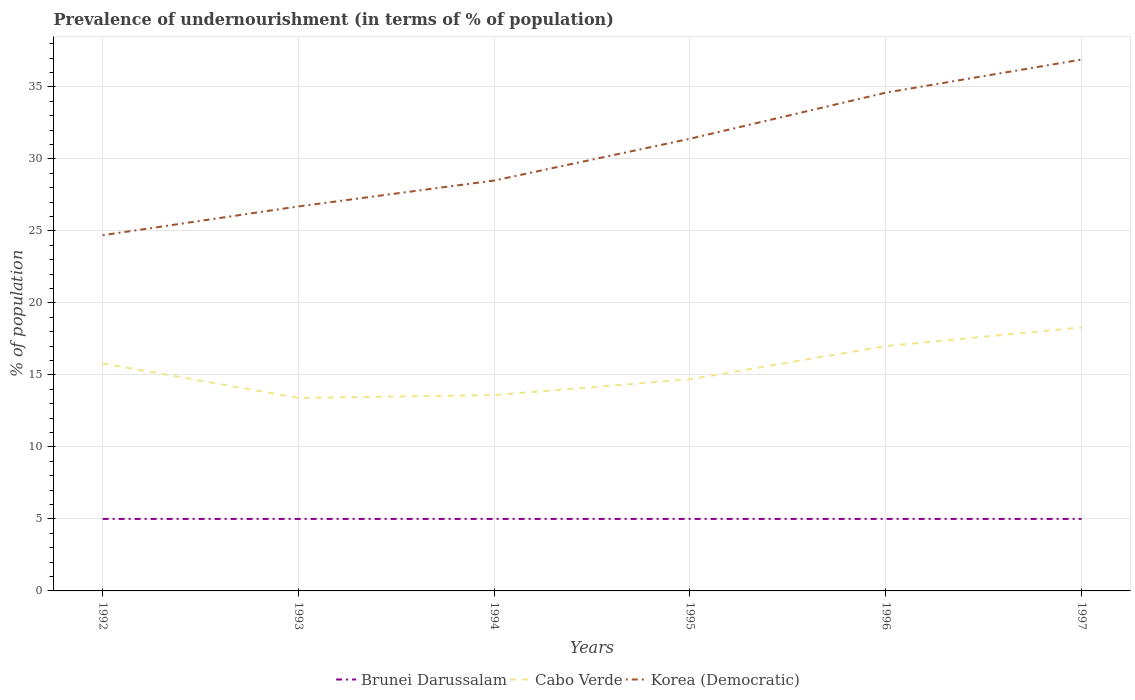Does the line corresponding to Korea (Democratic) intersect with the line corresponding to Cabo Verde?
Provide a succinct answer. No. Is the number of lines equal to the number of legend labels?
Ensure brevity in your answer.  Yes. Across all years, what is the maximum percentage of undernourished population in Cabo Verde?
Make the answer very short. 13.4. What is the total percentage of undernourished population in Korea (Democratic) in the graph?
Offer a terse response. -3.8. Is the percentage of undernourished population in Brunei Darussalam strictly greater than the percentage of undernourished population in Cabo Verde over the years?
Your answer should be compact. Yes. What is the difference between two consecutive major ticks on the Y-axis?
Provide a short and direct response. 5. Are the values on the major ticks of Y-axis written in scientific E-notation?
Provide a succinct answer. No. Does the graph contain any zero values?
Give a very brief answer. No. What is the title of the graph?
Make the answer very short. Prevalence of undernourishment (in terms of % of population). Does "Niger" appear as one of the legend labels in the graph?
Your answer should be compact. No. What is the label or title of the X-axis?
Provide a succinct answer. Years. What is the label or title of the Y-axis?
Your answer should be very brief. % of population. What is the % of population in Brunei Darussalam in 1992?
Offer a terse response. 5. What is the % of population of Cabo Verde in 1992?
Offer a very short reply. 15.8. What is the % of population in Korea (Democratic) in 1992?
Your answer should be compact. 24.7. What is the % of population in Korea (Democratic) in 1993?
Your response must be concise. 26.7. What is the % of population in Brunei Darussalam in 1994?
Make the answer very short. 5. What is the % of population of Korea (Democratic) in 1994?
Make the answer very short. 28.5. What is the % of population of Cabo Verde in 1995?
Ensure brevity in your answer.  14.7. What is the % of population of Korea (Democratic) in 1995?
Make the answer very short. 31.4. What is the % of population of Brunei Darussalam in 1996?
Make the answer very short. 5. What is the % of population of Cabo Verde in 1996?
Your answer should be compact. 17. What is the % of population in Korea (Democratic) in 1996?
Your answer should be very brief. 34.6. What is the % of population in Brunei Darussalam in 1997?
Offer a very short reply. 5. What is the % of population in Korea (Democratic) in 1997?
Provide a succinct answer. 36.9. Across all years, what is the maximum % of population in Cabo Verde?
Offer a terse response. 18.3. Across all years, what is the maximum % of population of Korea (Democratic)?
Make the answer very short. 36.9. Across all years, what is the minimum % of population of Brunei Darussalam?
Your response must be concise. 5. Across all years, what is the minimum % of population in Korea (Democratic)?
Give a very brief answer. 24.7. What is the total % of population of Brunei Darussalam in the graph?
Provide a succinct answer. 30. What is the total % of population of Cabo Verde in the graph?
Ensure brevity in your answer.  92.8. What is the total % of population in Korea (Democratic) in the graph?
Provide a short and direct response. 182.8. What is the difference between the % of population of Brunei Darussalam in 1992 and that in 1994?
Offer a terse response. 0. What is the difference between the % of population of Cabo Verde in 1992 and that in 1994?
Offer a very short reply. 2.2. What is the difference between the % of population of Korea (Democratic) in 1992 and that in 1994?
Provide a succinct answer. -3.8. What is the difference between the % of population in Brunei Darussalam in 1992 and that in 1995?
Your response must be concise. 0. What is the difference between the % of population in Cabo Verde in 1992 and that in 1995?
Make the answer very short. 1.1. What is the difference between the % of population of Cabo Verde in 1992 and that in 1997?
Provide a succinct answer. -2.5. What is the difference between the % of population in Korea (Democratic) in 1992 and that in 1997?
Provide a short and direct response. -12.2. What is the difference between the % of population in Brunei Darussalam in 1993 and that in 1994?
Your answer should be compact. 0. What is the difference between the % of population in Brunei Darussalam in 1993 and that in 1995?
Make the answer very short. 0. What is the difference between the % of population of Korea (Democratic) in 1993 and that in 1995?
Keep it short and to the point. -4.7. What is the difference between the % of population in Brunei Darussalam in 1993 and that in 1996?
Offer a terse response. 0. What is the difference between the % of population of Korea (Democratic) in 1993 and that in 1996?
Offer a very short reply. -7.9. What is the difference between the % of population of Cabo Verde in 1993 and that in 1997?
Offer a very short reply. -4.9. What is the difference between the % of population in Korea (Democratic) in 1993 and that in 1997?
Offer a very short reply. -10.2. What is the difference between the % of population in Cabo Verde in 1994 and that in 1995?
Offer a terse response. -1.1. What is the difference between the % of population of Korea (Democratic) in 1994 and that in 1995?
Provide a succinct answer. -2.9. What is the difference between the % of population of Brunei Darussalam in 1994 and that in 1997?
Provide a succinct answer. 0. What is the difference between the % of population in Cabo Verde in 1994 and that in 1997?
Your answer should be very brief. -4.7. What is the difference between the % of population in Cabo Verde in 1995 and that in 1996?
Offer a very short reply. -2.3. What is the difference between the % of population in Brunei Darussalam in 1995 and that in 1997?
Ensure brevity in your answer.  0. What is the difference between the % of population in Cabo Verde in 1995 and that in 1997?
Ensure brevity in your answer.  -3.6. What is the difference between the % of population in Korea (Democratic) in 1996 and that in 1997?
Keep it short and to the point. -2.3. What is the difference between the % of population in Brunei Darussalam in 1992 and the % of population in Cabo Verde in 1993?
Give a very brief answer. -8.4. What is the difference between the % of population of Brunei Darussalam in 1992 and the % of population of Korea (Democratic) in 1993?
Make the answer very short. -21.7. What is the difference between the % of population in Brunei Darussalam in 1992 and the % of population in Korea (Democratic) in 1994?
Ensure brevity in your answer.  -23.5. What is the difference between the % of population of Cabo Verde in 1992 and the % of population of Korea (Democratic) in 1994?
Your response must be concise. -12.7. What is the difference between the % of population of Brunei Darussalam in 1992 and the % of population of Korea (Democratic) in 1995?
Your answer should be compact. -26.4. What is the difference between the % of population of Cabo Verde in 1992 and the % of population of Korea (Democratic) in 1995?
Your response must be concise. -15.6. What is the difference between the % of population of Brunei Darussalam in 1992 and the % of population of Korea (Democratic) in 1996?
Offer a very short reply. -29.6. What is the difference between the % of population in Cabo Verde in 1992 and the % of population in Korea (Democratic) in 1996?
Make the answer very short. -18.8. What is the difference between the % of population in Brunei Darussalam in 1992 and the % of population in Cabo Verde in 1997?
Your answer should be very brief. -13.3. What is the difference between the % of population of Brunei Darussalam in 1992 and the % of population of Korea (Democratic) in 1997?
Offer a very short reply. -31.9. What is the difference between the % of population in Cabo Verde in 1992 and the % of population in Korea (Democratic) in 1997?
Offer a terse response. -21.1. What is the difference between the % of population of Brunei Darussalam in 1993 and the % of population of Cabo Verde in 1994?
Provide a short and direct response. -8.6. What is the difference between the % of population of Brunei Darussalam in 1993 and the % of population of Korea (Democratic) in 1994?
Offer a terse response. -23.5. What is the difference between the % of population of Cabo Verde in 1993 and the % of population of Korea (Democratic) in 1994?
Your answer should be very brief. -15.1. What is the difference between the % of population in Brunei Darussalam in 1993 and the % of population in Korea (Democratic) in 1995?
Keep it short and to the point. -26.4. What is the difference between the % of population in Cabo Verde in 1993 and the % of population in Korea (Democratic) in 1995?
Your answer should be compact. -18. What is the difference between the % of population in Brunei Darussalam in 1993 and the % of population in Cabo Verde in 1996?
Offer a very short reply. -12. What is the difference between the % of population of Brunei Darussalam in 1993 and the % of population of Korea (Democratic) in 1996?
Your response must be concise. -29.6. What is the difference between the % of population in Cabo Verde in 1993 and the % of population in Korea (Democratic) in 1996?
Offer a very short reply. -21.2. What is the difference between the % of population in Brunei Darussalam in 1993 and the % of population in Korea (Democratic) in 1997?
Your answer should be compact. -31.9. What is the difference between the % of population of Cabo Verde in 1993 and the % of population of Korea (Democratic) in 1997?
Provide a short and direct response. -23.5. What is the difference between the % of population of Brunei Darussalam in 1994 and the % of population of Cabo Verde in 1995?
Make the answer very short. -9.7. What is the difference between the % of population of Brunei Darussalam in 1994 and the % of population of Korea (Democratic) in 1995?
Keep it short and to the point. -26.4. What is the difference between the % of population of Cabo Verde in 1994 and the % of population of Korea (Democratic) in 1995?
Offer a terse response. -17.8. What is the difference between the % of population in Brunei Darussalam in 1994 and the % of population in Cabo Verde in 1996?
Make the answer very short. -12. What is the difference between the % of population in Brunei Darussalam in 1994 and the % of population in Korea (Democratic) in 1996?
Give a very brief answer. -29.6. What is the difference between the % of population in Cabo Verde in 1994 and the % of population in Korea (Democratic) in 1996?
Give a very brief answer. -21. What is the difference between the % of population in Brunei Darussalam in 1994 and the % of population in Cabo Verde in 1997?
Offer a very short reply. -13.3. What is the difference between the % of population of Brunei Darussalam in 1994 and the % of population of Korea (Democratic) in 1997?
Your answer should be compact. -31.9. What is the difference between the % of population of Cabo Verde in 1994 and the % of population of Korea (Democratic) in 1997?
Offer a very short reply. -23.3. What is the difference between the % of population in Brunei Darussalam in 1995 and the % of population in Cabo Verde in 1996?
Ensure brevity in your answer.  -12. What is the difference between the % of population in Brunei Darussalam in 1995 and the % of population in Korea (Democratic) in 1996?
Your answer should be very brief. -29.6. What is the difference between the % of population of Cabo Verde in 1995 and the % of population of Korea (Democratic) in 1996?
Give a very brief answer. -19.9. What is the difference between the % of population in Brunei Darussalam in 1995 and the % of population in Cabo Verde in 1997?
Provide a short and direct response. -13.3. What is the difference between the % of population in Brunei Darussalam in 1995 and the % of population in Korea (Democratic) in 1997?
Provide a succinct answer. -31.9. What is the difference between the % of population of Cabo Verde in 1995 and the % of population of Korea (Democratic) in 1997?
Offer a terse response. -22.2. What is the difference between the % of population of Brunei Darussalam in 1996 and the % of population of Korea (Democratic) in 1997?
Keep it short and to the point. -31.9. What is the difference between the % of population in Cabo Verde in 1996 and the % of population in Korea (Democratic) in 1997?
Provide a short and direct response. -19.9. What is the average % of population of Cabo Verde per year?
Provide a short and direct response. 15.47. What is the average % of population of Korea (Democratic) per year?
Your answer should be very brief. 30.47. In the year 1992, what is the difference between the % of population in Brunei Darussalam and % of population in Cabo Verde?
Ensure brevity in your answer.  -10.8. In the year 1992, what is the difference between the % of population of Brunei Darussalam and % of population of Korea (Democratic)?
Keep it short and to the point. -19.7. In the year 1992, what is the difference between the % of population in Cabo Verde and % of population in Korea (Democratic)?
Offer a terse response. -8.9. In the year 1993, what is the difference between the % of population of Brunei Darussalam and % of population of Cabo Verde?
Keep it short and to the point. -8.4. In the year 1993, what is the difference between the % of population in Brunei Darussalam and % of population in Korea (Democratic)?
Offer a very short reply. -21.7. In the year 1994, what is the difference between the % of population in Brunei Darussalam and % of population in Cabo Verde?
Your answer should be compact. -8.6. In the year 1994, what is the difference between the % of population of Brunei Darussalam and % of population of Korea (Democratic)?
Provide a short and direct response. -23.5. In the year 1994, what is the difference between the % of population in Cabo Verde and % of population in Korea (Democratic)?
Provide a succinct answer. -14.9. In the year 1995, what is the difference between the % of population of Brunei Darussalam and % of population of Cabo Verde?
Offer a very short reply. -9.7. In the year 1995, what is the difference between the % of population in Brunei Darussalam and % of population in Korea (Democratic)?
Keep it short and to the point. -26.4. In the year 1995, what is the difference between the % of population of Cabo Verde and % of population of Korea (Democratic)?
Give a very brief answer. -16.7. In the year 1996, what is the difference between the % of population in Brunei Darussalam and % of population in Cabo Verde?
Your answer should be compact. -12. In the year 1996, what is the difference between the % of population of Brunei Darussalam and % of population of Korea (Democratic)?
Your answer should be very brief. -29.6. In the year 1996, what is the difference between the % of population in Cabo Verde and % of population in Korea (Democratic)?
Provide a succinct answer. -17.6. In the year 1997, what is the difference between the % of population of Brunei Darussalam and % of population of Cabo Verde?
Your response must be concise. -13.3. In the year 1997, what is the difference between the % of population in Brunei Darussalam and % of population in Korea (Democratic)?
Keep it short and to the point. -31.9. In the year 1997, what is the difference between the % of population of Cabo Verde and % of population of Korea (Democratic)?
Keep it short and to the point. -18.6. What is the ratio of the % of population of Brunei Darussalam in 1992 to that in 1993?
Your answer should be compact. 1. What is the ratio of the % of population of Cabo Verde in 1992 to that in 1993?
Offer a terse response. 1.18. What is the ratio of the % of population of Korea (Democratic) in 1992 to that in 1993?
Your response must be concise. 0.93. What is the ratio of the % of population of Cabo Verde in 1992 to that in 1994?
Provide a short and direct response. 1.16. What is the ratio of the % of population of Korea (Democratic) in 1992 to that in 1994?
Ensure brevity in your answer.  0.87. What is the ratio of the % of population of Brunei Darussalam in 1992 to that in 1995?
Ensure brevity in your answer.  1. What is the ratio of the % of population of Cabo Verde in 1992 to that in 1995?
Offer a very short reply. 1.07. What is the ratio of the % of population of Korea (Democratic) in 1992 to that in 1995?
Offer a terse response. 0.79. What is the ratio of the % of population of Brunei Darussalam in 1992 to that in 1996?
Your response must be concise. 1. What is the ratio of the % of population of Cabo Verde in 1992 to that in 1996?
Offer a very short reply. 0.93. What is the ratio of the % of population in Korea (Democratic) in 1992 to that in 1996?
Provide a short and direct response. 0.71. What is the ratio of the % of population of Brunei Darussalam in 1992 to that in 1997?
Give a very brief answer. 1. What is the ratio of the % of population of Cabo Verde in 1992 to that in 1997?
Provide a short and direct response. 0.86. What is the ratio of the % of population in Korea (Democratic) in 1992 to that in 1997?
Your response must be concise. 0.67. What is the ratio of the % of population of Brunei Darussalam in 1993 to that in 1994?
Make the answer very short. 1. What is the ratio of the % of population in Korea (Democratic) in 1993 to that in 1994?
Offer a terse response. 0.94. What is the ratio of the % of population in Brunei Darussalam in 1993 to that in 1995?
Give a very brief answer. 1. What is the ratio of the % of population in Cabo Verde in 1993 to that in 1995?
Ensure brevity in your answer.  0.91. What is the ratio of the % of population of Korea (Democratic) in 1993 to that in 1995?
Your response must be concise. 0.85. What is the ratio of the % of population of Brunei Darussalam in 1993 to that in 1996?
Your response must be concise. 1. What is the ratio of the % of population in Cabo Verde in 1993 to that in 1996?
Give a very brief answer. 0.79. What is the ratio of the % of population of Korea (Democratic) in 1993 to that in 1996?
Provide a short and direct response. 0.77. What is the ratio of the % of population of Brunei Darussalam in 1993 to that in 1997?
Keep it short and to the point. 1. What is the ratio of the % of population of Cabo Verde in 1993 to that in 1997?
Keep it short and to the point. 0.73. What is the ratio of the % of population in Korea (Democratic) in 1993 to that in 1997?
Provide a short and direct response. 0.72. What is the ratio of the % of population in Cabo Verde in 1994 to that in 1995?
Offer a very short reply. 0.93. What is the ratio of the % of population of Korea (Democratic) in 1994 to that in 1995?
Keep it short and to the point. 0.91. What is the ratio of the % of population in Korea (Democratic) in 1994 to that in 1996?
Your response must be concise. 0.82. What is the ratio of the % of population of Cabo Verde in 1994 to that in 1997?
Offer a terse response. 0.74. What is the ratio of the % of population in Korea (Democratic) in 1994 to that in 1997?
Provide a short and direct response. 0.77. What is the ratio of the % of population of Cabo Verde in 1995 to that in 1996?
Your response must be concise. 0.86. What is the ratio of the % of population in Korea (Democratic) in 1995 to that in 1996?
Your response must be concise. 0.91. What is the ratio of the % of population of Cabo Verde in 1995 to that in 1997?
Offer a very short reply. 0.8. What is the ratio of the % of population of Korea (Democratic) in 1995 to that in 1997?
Your response must be concise. 0.85. What is the ratio of the % of population of Cabo Verde in 1996 to that in 1997?
Offer a terse response. 0.93. What is the ratio of the % of population of Korea (Democratic) in 1996 to that in 1997?
Offer a very short reply. 0.94. What is the difference between the highest and the second highest % of population of Brunei Darussalam?
Keep it short and to the point. 0. What is the difference between the highest and the second highest % of population in Cabo Verde?
Your answer should be very brief. 1.3. What is the difference between the highest and the lowest % of population of Brunei Darussalam?
Provide a succinct answer. 0. What is the difference between the highest and the lowest % of population in Cabo Verde?
Your answer should be very brief. 4.9. What is the difference between the highest and the lowest % of population in Korea (Democratic)?
Ensure brevity in your answer.  12.2. 